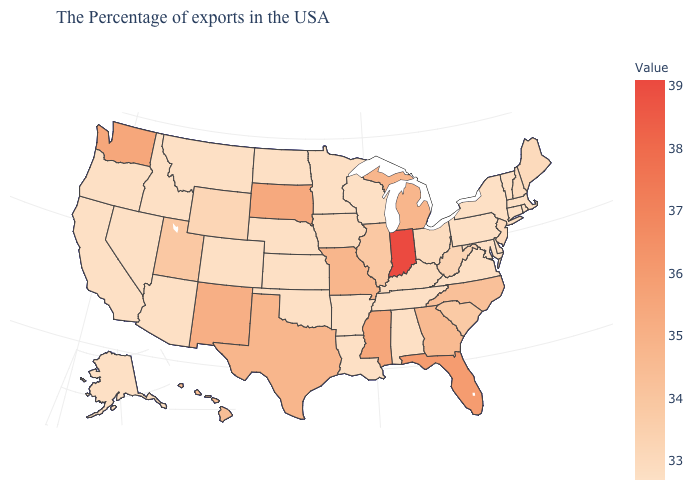Is the legend a continuous bar?
Give a very brief answer. Yes. Which states have the lowest value in the South?
Be succinct. Delaware, Maryland, Virginia, Alabama, Tennessee, Louisiana, Arkansas, Oklahoma. Which states have the lowest value in the USA?
Write a very short answer. Massachusetts, Rhode Island, Vermont, Connecticut, New York, Delaware, Maryland, Pennsylvania, Virginia, Alabama, Tennessee, Wisconsin, Louisiana, Arkansas, Minnesota, Kansas, Nebraska, Oklahoma, North Dakota, Colorado, Montana, Arizona, Idaho, Nevada, California, Oregon, Alaska. Does Connecticut have the highest value in the Northeast?
Short answer required. No. Among the states that border Indiana , does Ohio have the lowest value?
Short answer required. Yes. Is the legend a continuous bar?
Concise answer only. Yes. Among the states that border South Carolina , does Georgia have the lowest value?
Quick response, please. No. 